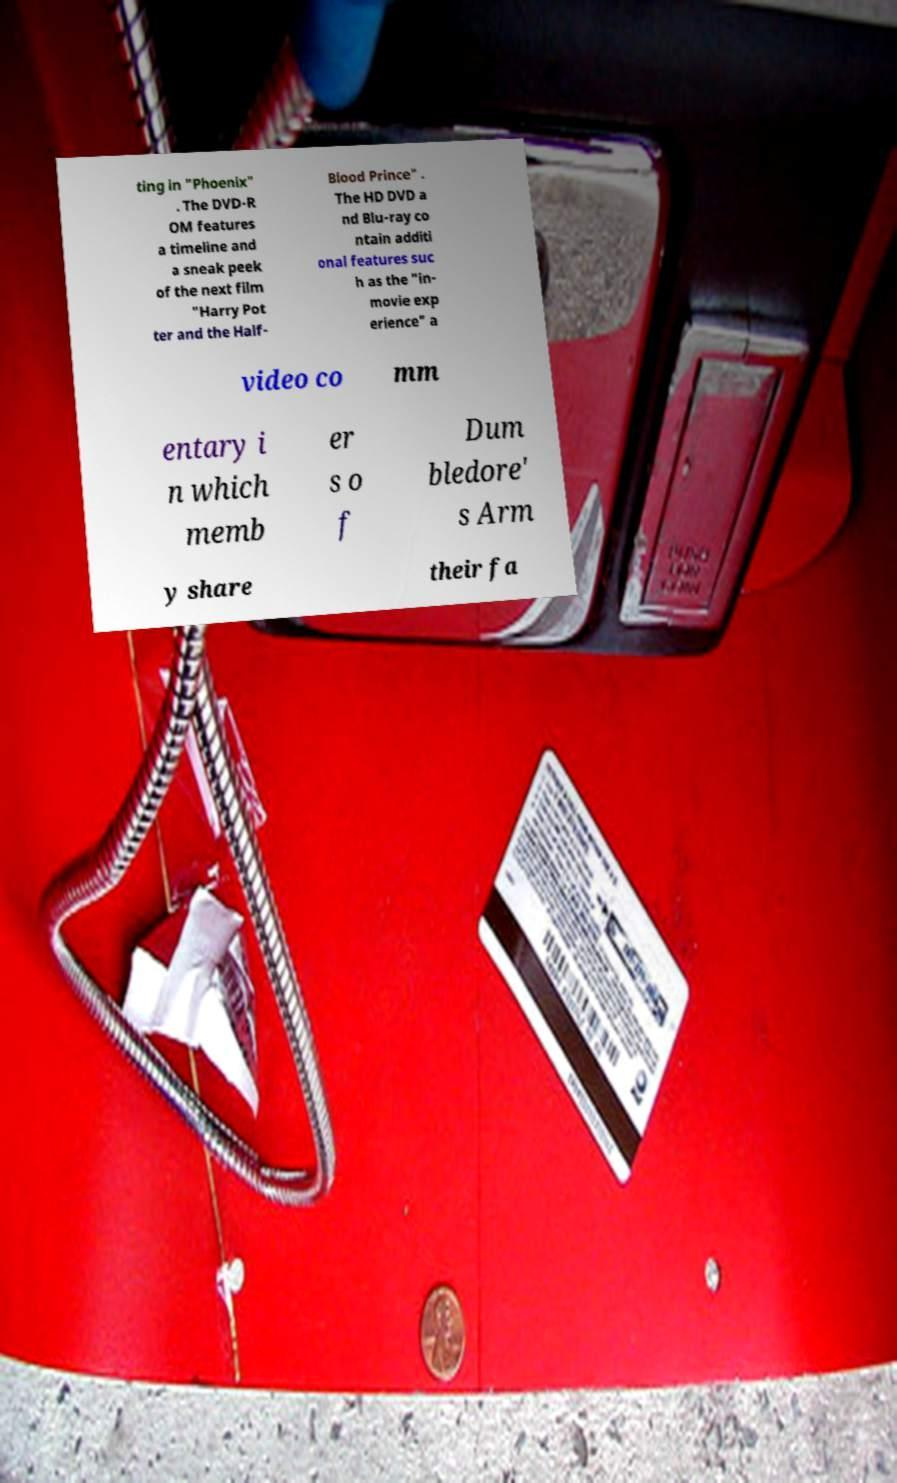I need the written content from this picture converted into text. Can you do that? ting in "Phoenix" . The DVD-R OM features a timeline and a sneak peek of the next film "Harry Pot ter and the Half- Blood Prince" . The HD DVD a nd Blu-ray co ntain additi onal features suc h as the "in- movie exp erience" a video co mm entary i n which memb er s o f Dum bledore' s Arm y share their fa 